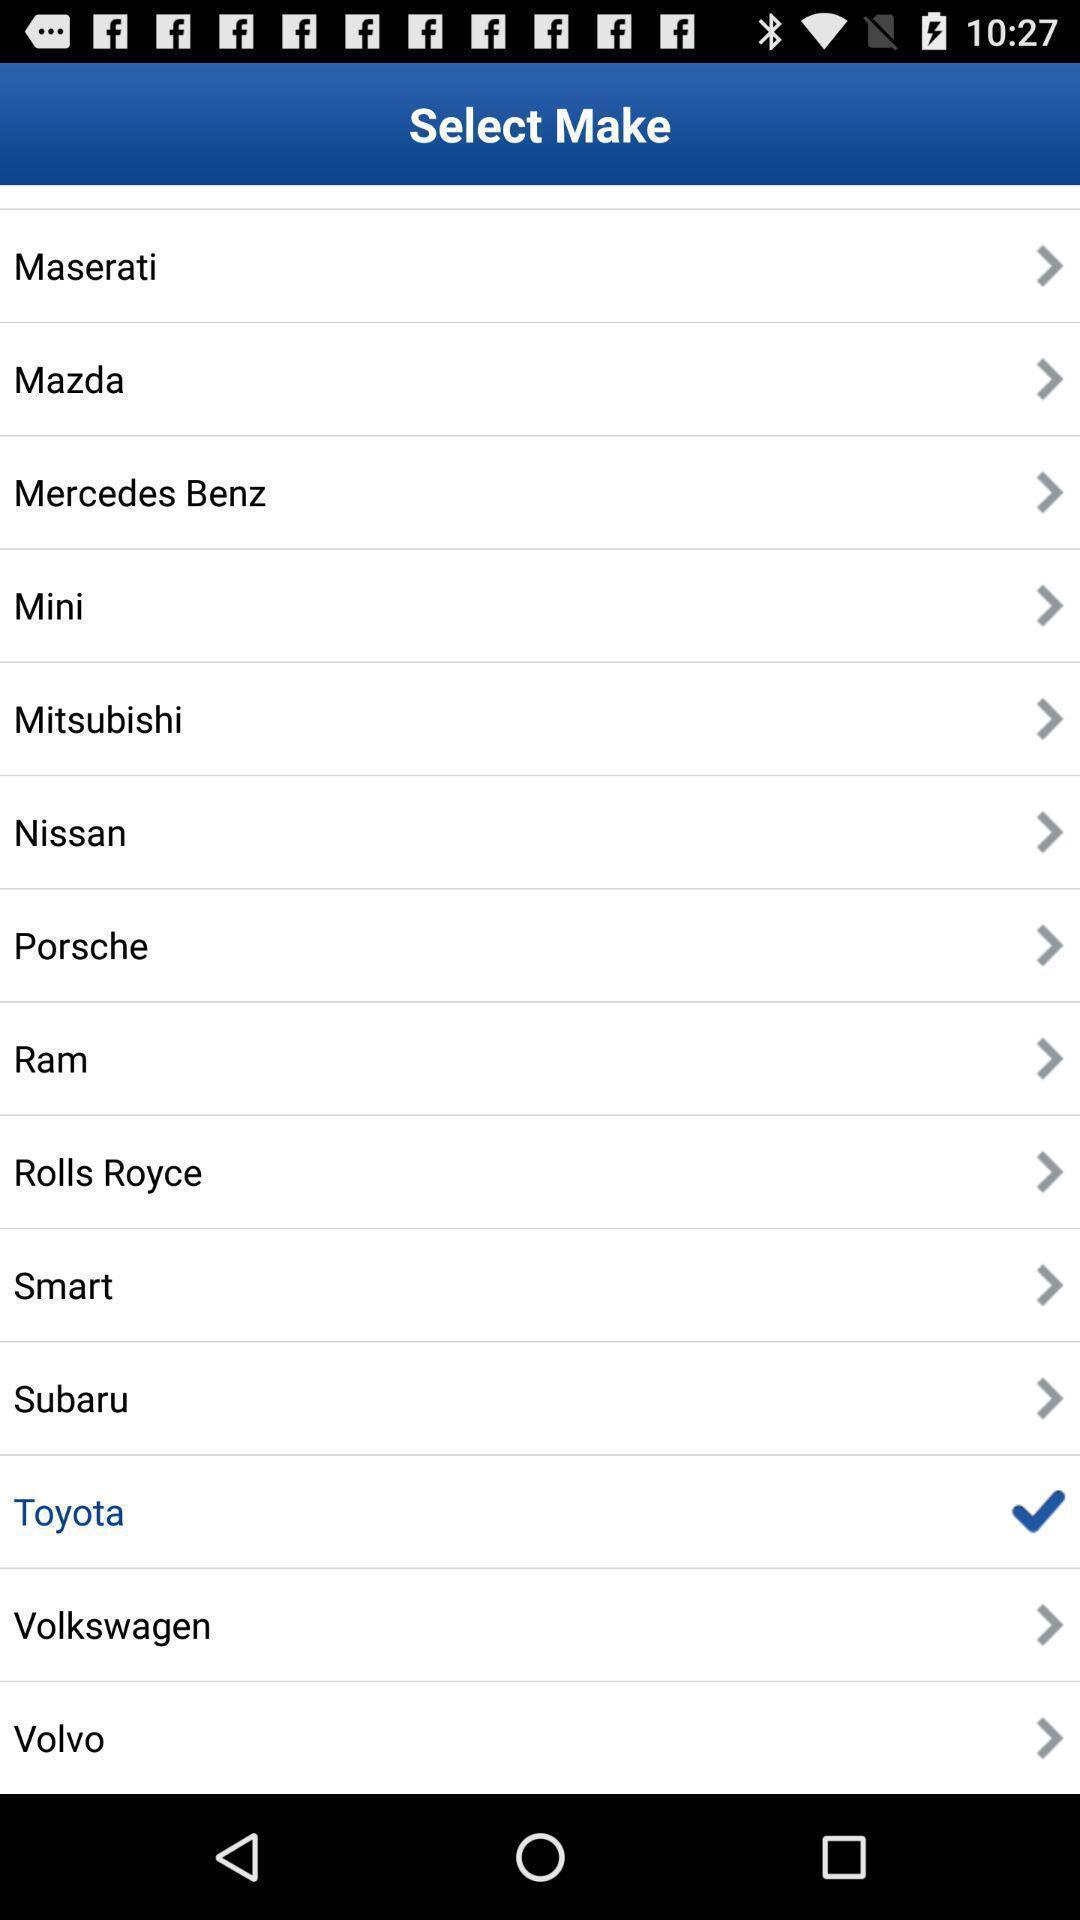Describe the visual elements of this screenshot. Screen displaying the options to select. 